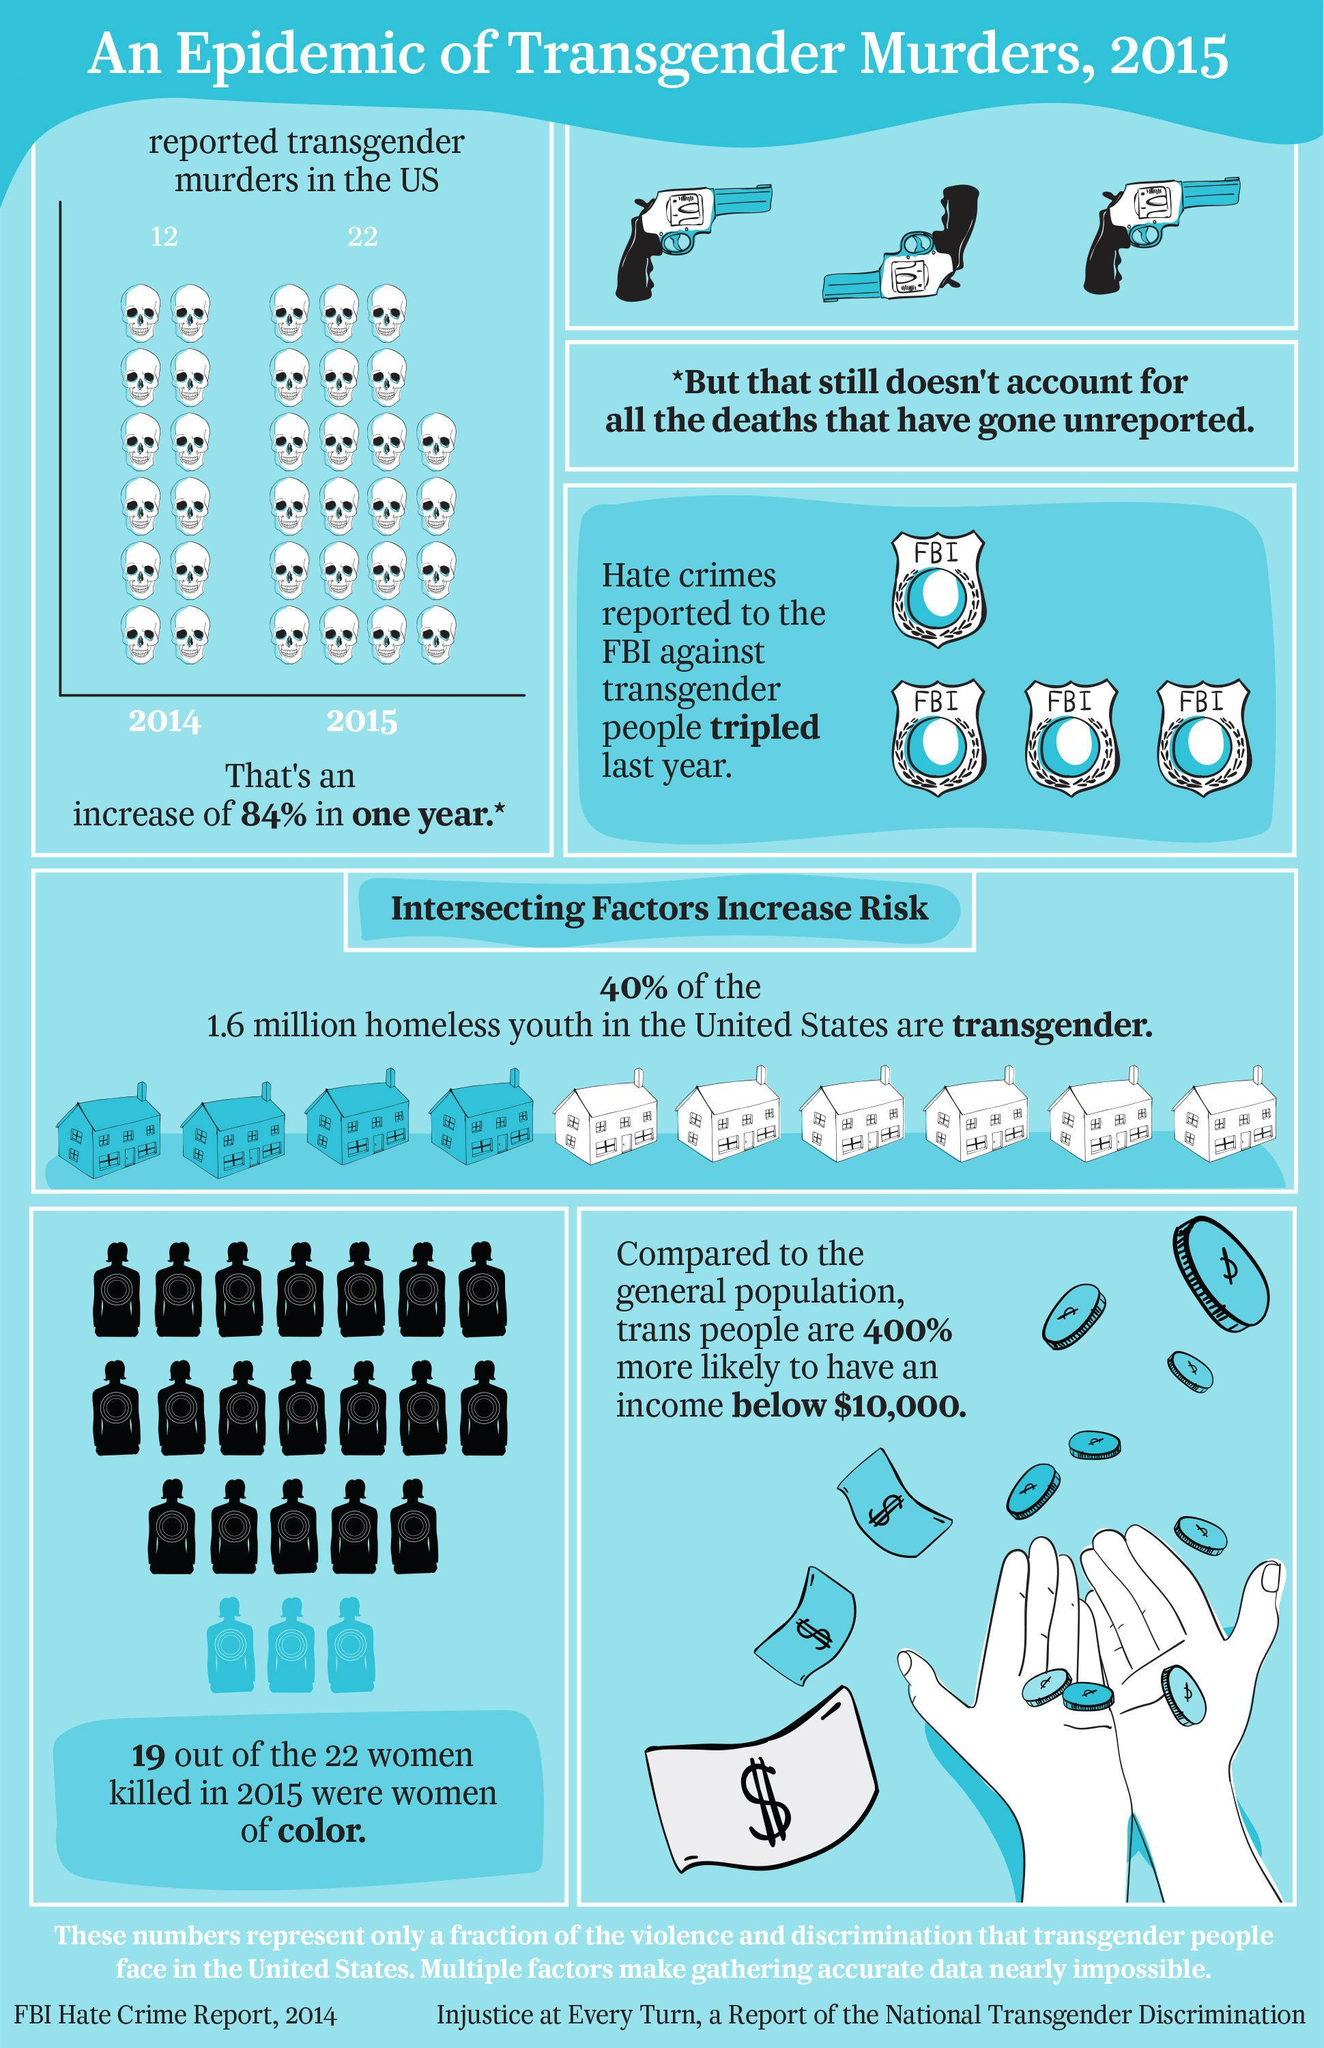Highlight a few significant elements in this photo. According to estimates, there are approximately 640,000 homeless transgender youth in the United States. There was a significant increase in reported transgender murders in the United States from 2014 to 2015, with a tenfold increase observed. 